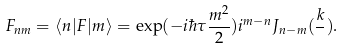<formula> <loc_0><loc_0><loc_500><loc_500>F _ { n m } = \langle n | F | m \rangle = \exp ( - i \hbar { \tau } \frac { m ^ { 2 } } { 2 } ) i ^ { m - n } J _ { n - m } ( \frac { k } { } ) .</formula> 